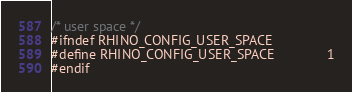Convert code to text. <code><loc_0><loc_0><loc_500><loc_500><_C_>

/* user space */
#ifndef RHINO_CONFIG_USER_SPACE
#define RHINO_CONFIG_USER_SPACE              1
#endif

</code> 